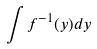<formula> <loc_0><loc_0><loc_500><loc_500>\int f ^ { - 1 } ( y ) d y</formula> 